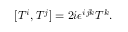Convert formula to latex. <formula><loc_0><loc_0><loc_500><loc_500>[ T ^ { i } , T ^ { j } ] = 2 i \epsilon ^ { i j k } T ^ { k } .</formula> 